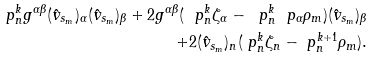Convert formula to latex. <formula><loc_0><loc_0><loc_500><loc_500>\ p _ { n } ^ { k } g ^ { \alpha \beta } ( \hat { v } _ { s _ { m } } ) _ { \alpha } ( \hat { v } _ { s _ { m } } ) _ { \beta } + 2 g ^ { \alpha \beta } ( \ p _ { n } ^ { k } \zeta _ { \alpha } - \ p _ { n } ^ { k } \ p _ { \alpha } \rho _ { m } ) ( \hat { v } _ { s _ { m } } ) _ { \beta } \\ + 2 ( \hat { v } _ { s _ { m } } ) _ { n } ( \ p _ { n } ^ { k } \zeta _ { n } - \ p _ { n } ^ { k + 1 } \rho _ { m } ) .</formula> 